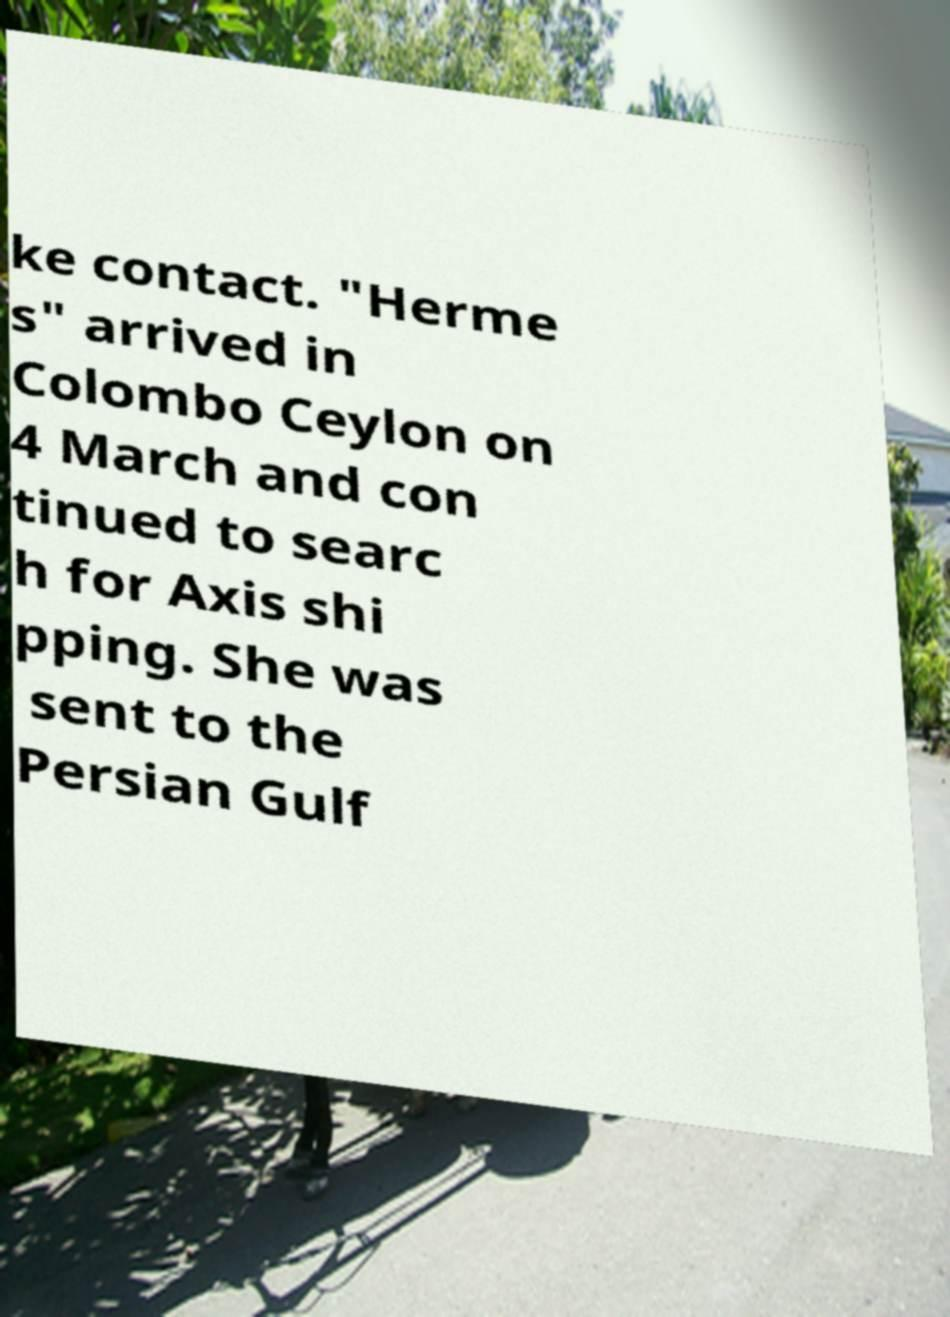Please identify and transcribe the text found in this image. ke contact. "Herme s" arrived in Colombo Ceylon on 4 March and con tinued to searc h for Axis shi pping. She was sent to the Persian Gulf 